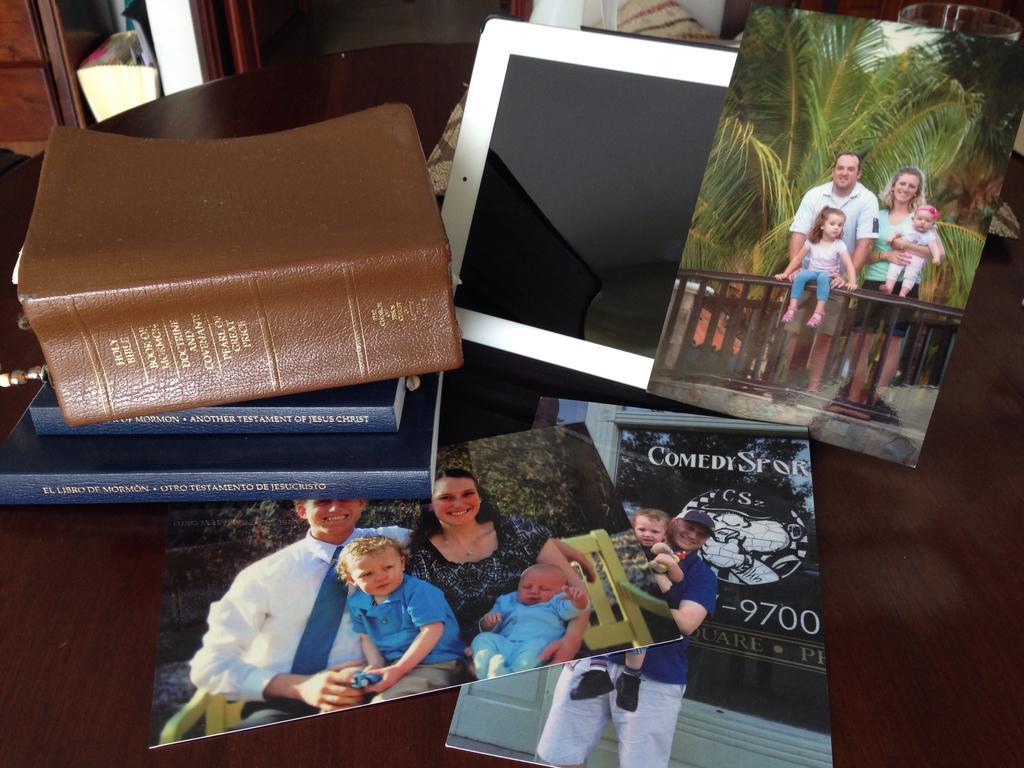Can you describe this image briefly? In this image I can see books and photographs of people. 